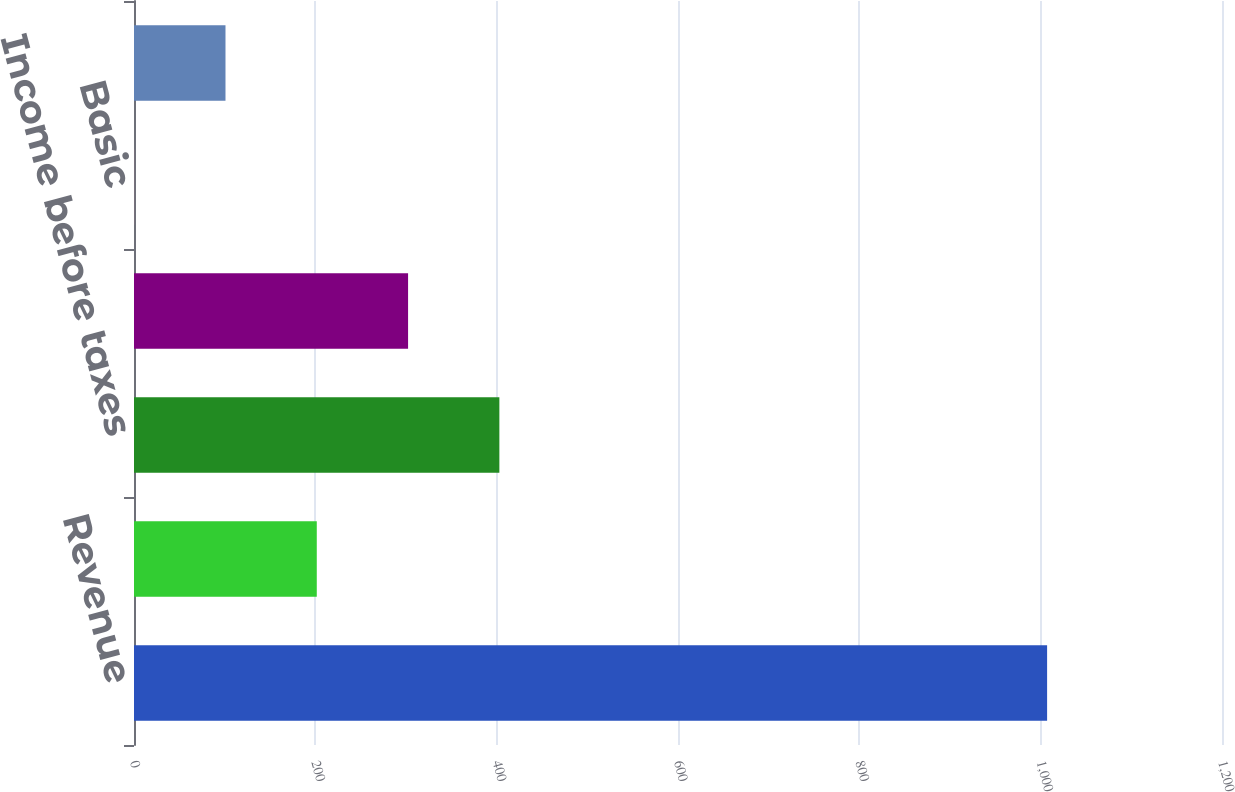Convert chart. <chart><loc_0><loc_0><loc_500><loc_500><bar_chart><fcel>Revenue<fcel>Operating income<fcel>Income before taxes<fcel>Net income<fcel>Basic<fcel>Diluted<nl><fcel>1007.1<fcel>201.6<fcel>402.98<fcel>302.29<fcel>0.22<fcel>100.91<nl></chart> 